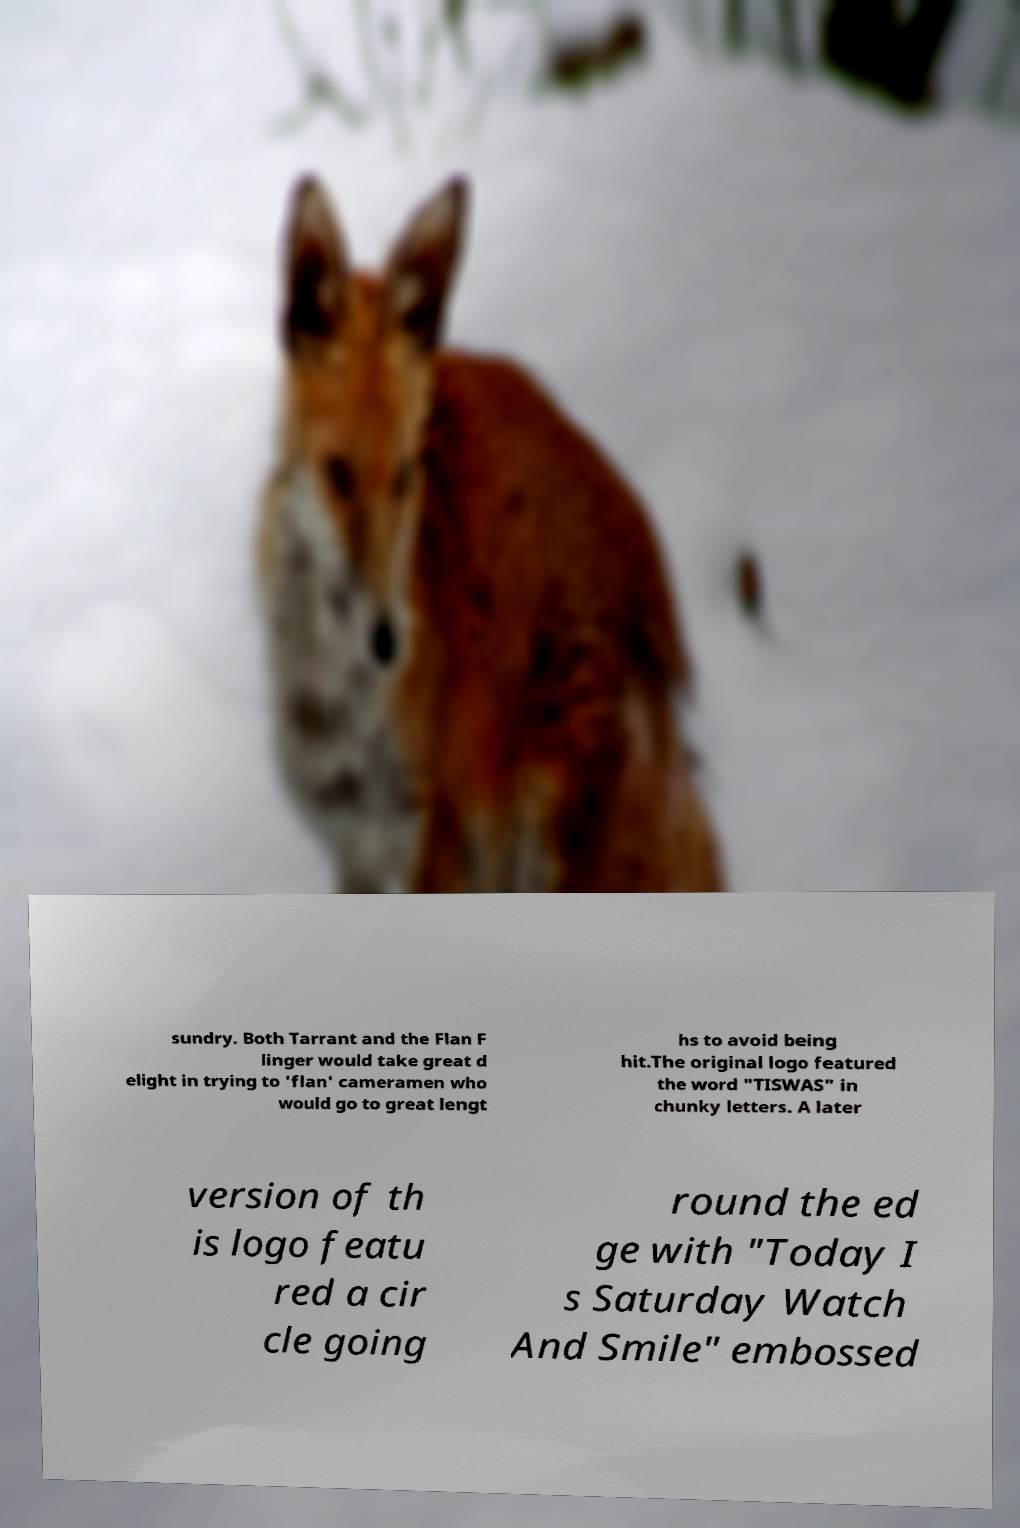For documentation purposes, I need the text within this image transcribed. Could you provide that? sundry. Both Tarrant and the Flan F linger would take great d elight in trying to 'flan' cameramen who would go to great lengt hs to avoid being hit.The original logo featured the word "TISWAS" in chunky letters. A later version of th is logo featu red a cir cle going round the ed ge with "Today I s Saturday Watch And Smile" embossed 